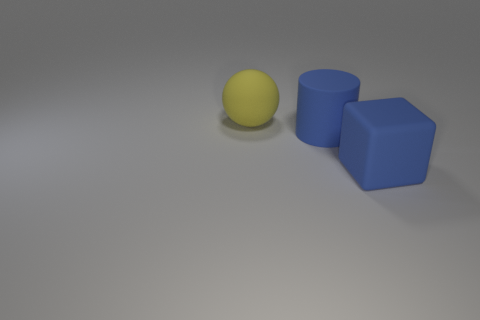Are there fewer large rubber spheres than cyan things?
Your answer should be compact. No. What number of other objects are the same color as the matte cube?
Make the answer very short. 1. Do the large object in front of the large cylinder and the large ball have the same material?
Give a very brief answer. Yes. There is a blue object in front of the blue rubber cylinder; what material is it?
Keep it short and to the point. Rubber. Is there a big blue block made of the same material as the yellow object?
Your response must be concise. Yes. The blue matte thing behind the large blue matte thing that is in front of the big blue thing left of the large matte block is what shape?
Offer a terse response. Cylinder. Do the big matte cylinder behind the blue cube and the matte object to the right of the blue matte cylinder have the same color?
Your answer should be compact. Yes. There is a rubber cube; are there any big blue matte objects on the left side of it?
Make the answer very short. Yes. The big matte object that is to the right of the large blue thing that is left of the large thing that is to the right of the big cylinder is what color?
Your answer should be compact. Blue. Do the block that is to the right of the cylinder and the object behind the rubber cylinder have the same material?
Keep it short and to the point. Yes. 